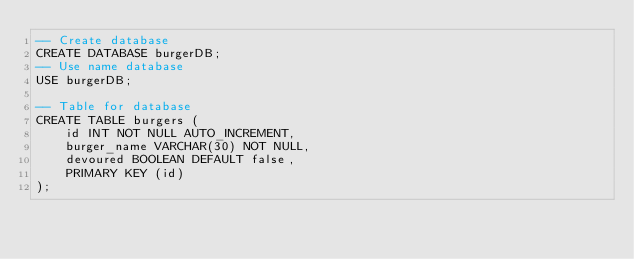<code> <loc_0><loc_0><loc_500><loc_500><_SQL_>-- Create database
CREATE DATABASE burgerDB;
-- Use name database
USE burgerDB;

-- Table for database
CREATE TABLE burgers (
    id INT NOT NULL AUTO_INCREMENT,
    burger_name VARCHAR(30) NOT NULL,
    devoured BOOLEAN DEFAULT false,
    PRIMARY KEY (id)
);
</code> 